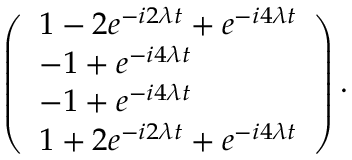Convert formula to latex. <formula><loc_0><loc_0><loc_500><loc_500>\left ( \begin{array} { l } { 1 - 2 e ^ { - i 2 \lambda t } + e ^ { - i 4 \lambda t } } \\ { - 1 + e ^ { - i 4 \lambda t } } \\ { - 1 + e ^ { - i 4 \lambda t } } \\ { 1 + 2 e ^ { - i 2 \lambda t } + e ^ { - i 4 \lambda t } } \end{array} \right ) .</formula> 